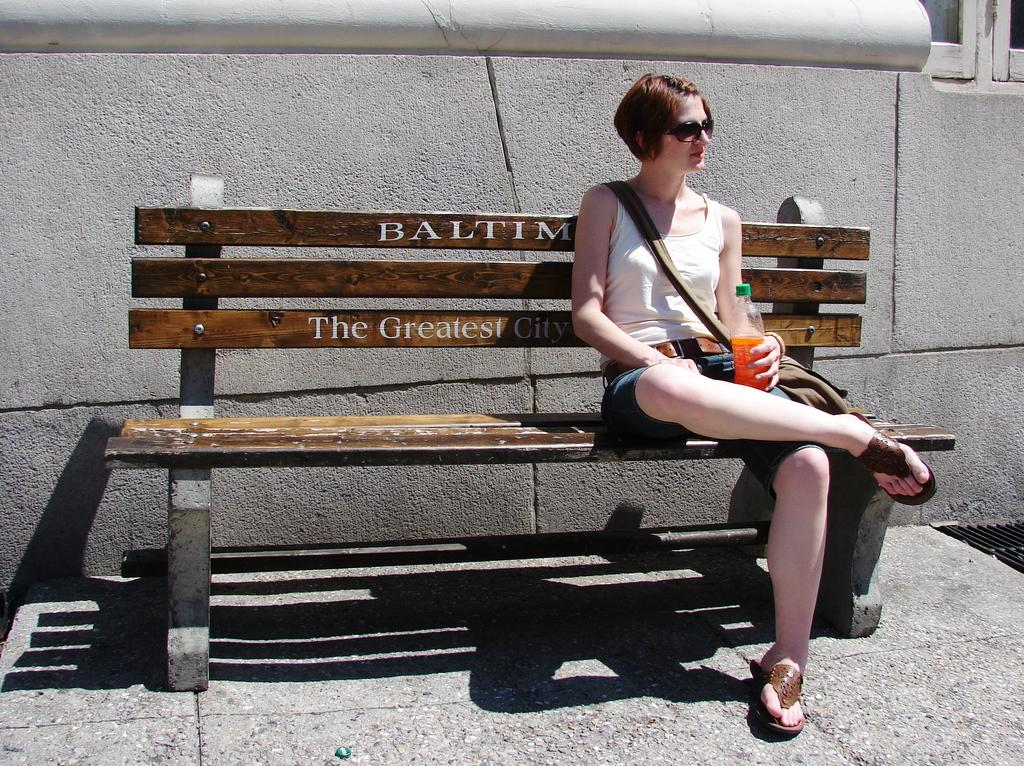Who is present in the image? There is a woman in the image. What is the woman doing in the image? The woman is sitting on a bench. What is the woman holding in the image? The woman is holding a bottle. What can be seen behind the woman in the image? There is a wall behind the woman. How many lizards are crawling on the woman's shoulder in the image? There are no lizards present in the image. What type of tub is visible in the image? There is no tub present in the image. 